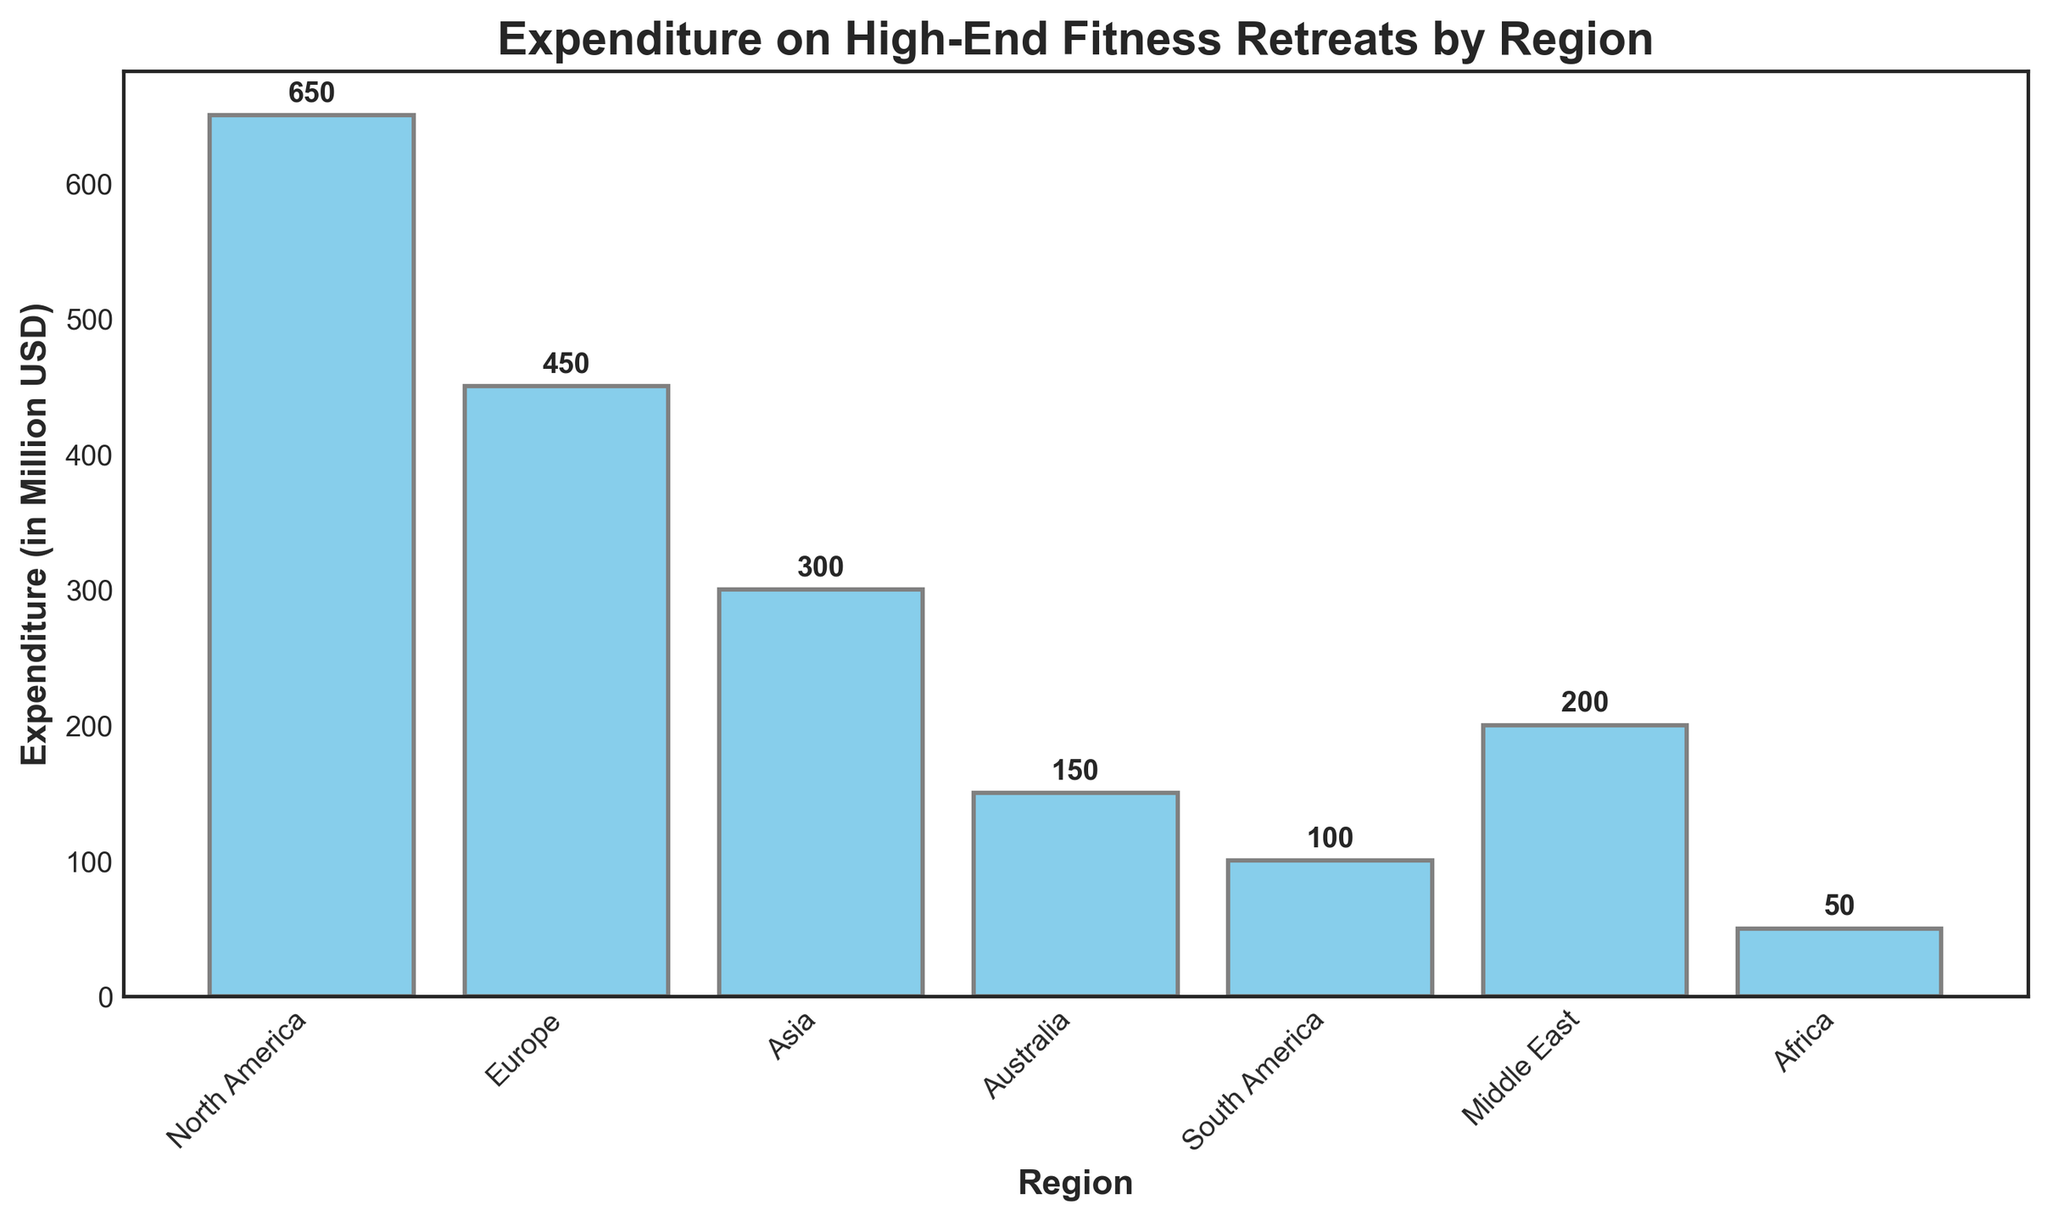What is the total expenditure on high-end fitness retreats for North America and Europe combined? The expenditure for North America is 650 million USD and for Europe is 450 million USD. Adding these values together, 650 + 450 = 1100 million USD.
Answer: 1100 million USD Which region has the lowest expenditure on high-end fitness retreats? By examining the bar chart, the region with the lowest bar is Africa, indicating the lowest expenditure at 50 million USD.
Answer: Africa How much more does North America spend on high-end fitness retreats compared to Asia? North America's expenditure is 650 million USD, while Asia's is 300 million USD. Subtracting Asia's expenditure from North America's gives 650 - 300 = 350 million USD.
Answer: 350 million USD What is the average expenditure on high-end fitness retreats across all regions? Summing up all the expenditures: 650 + 450 + 300 + 150 + 100 + 200 + 50 = 1900 million USD. There are 7 regions, so the average expenditure is 1900 / 7 ≈ 271.43 million USD.
Answer: 271.43 million USD Which regions spend more than 200 million USD on high-end fitness retreats? By looking at the bar heights, North America (650), Europe (450), and Asia (300) have bars exceeding 200 million USD.
Answer: North America, Europe, Asia What is the difference in expenditure between the region with the highest and the lowest spending? The highest expenditure is North America at 650 million USD, and the lowest is Africa at 50 million USD. The difference is 650 - 50 = 600 million USD.
Answer: 600 million USD Is the expenditure on high-end fitness retreats in the Middle East higher or lower than in South America? The expenditure for the Middle East is 200 million USD and for South America is 100 million USD. The Middle East spends more.
Answer: Higher What is the combined expenditure for the regions that spend less than 200 million USD each on high-end fitness retreats? Regions spending less than 200 million USD are Australia (150), South America (100), and Africa (50). The combined expenditure is 150 + 100 + 50 = 300 million USD.
Answer: 300 million USD What is the median expenditure on high-end fitness retreats across all regions? Ordering the expenditures: 50 (Africa), 100 (South America), 150 (Australia), 200 (Middle East), 300 (Asia), 450 (Europe), 650 (North America). The median value, being in the middle position, is 200 million USD (Middle East).
Answer: 200 million USD 